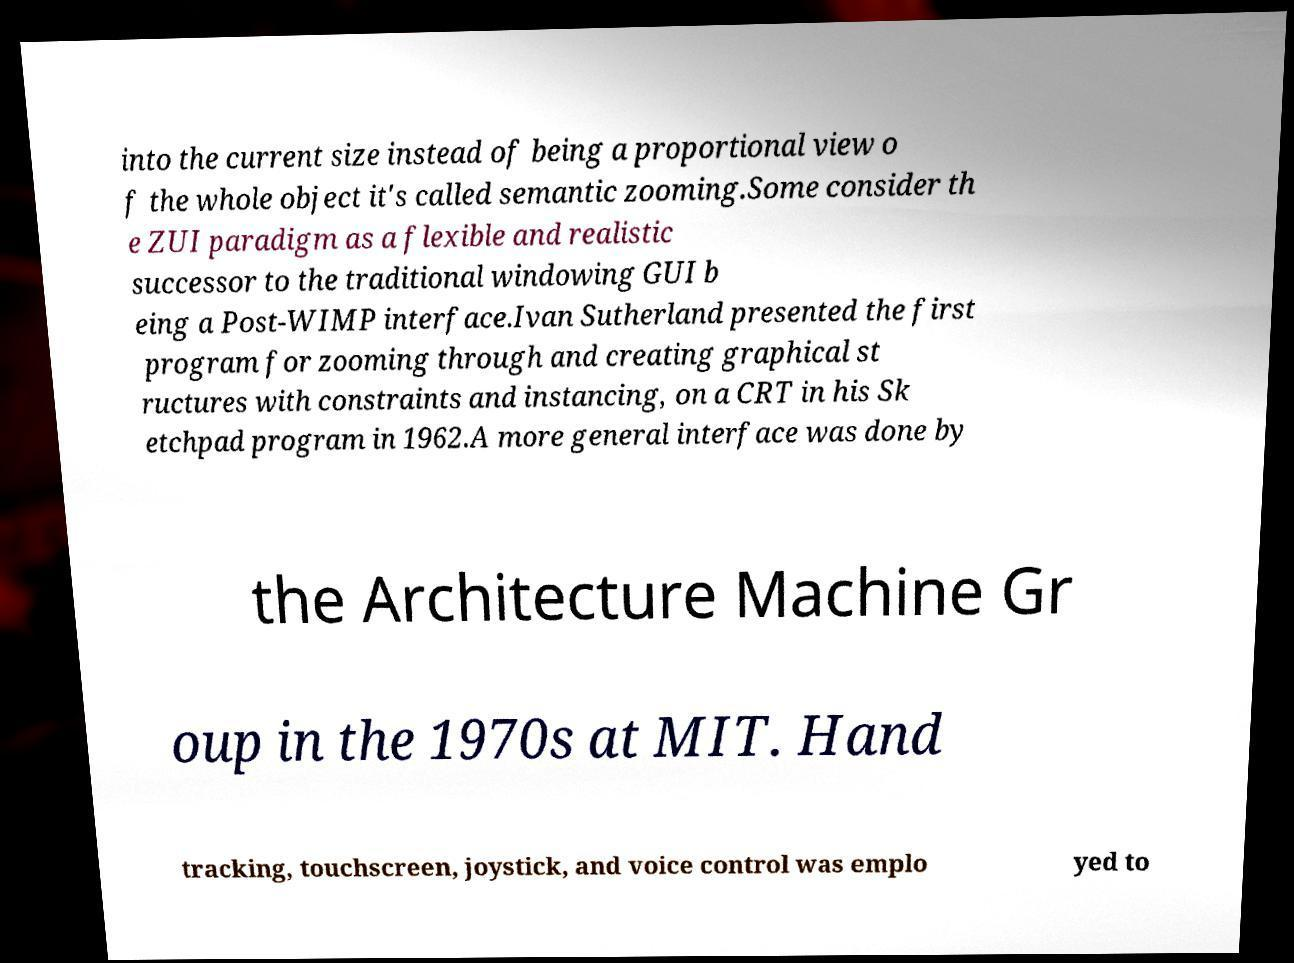Can you accurately transcribe the text from the provided image for me? into the current size instead of being a proportional view o f the whole object it's called semantic zooming.Some consider th e ZUI paradigm as a flexible and realistic successor to the traditional windowing GUI b eing a Post-WIMP interface.Ivan Sutherland presented the first program for zooming through and creating graphical st ructures with constraints and instancing, on a CRT in his Sk etchpad program in 1962.A more general interface was done by the Architecture Machine Gr oup in the 1970s at MIT. Hand tracking, touchscreen, joystick, and voice control was emplo yed to 